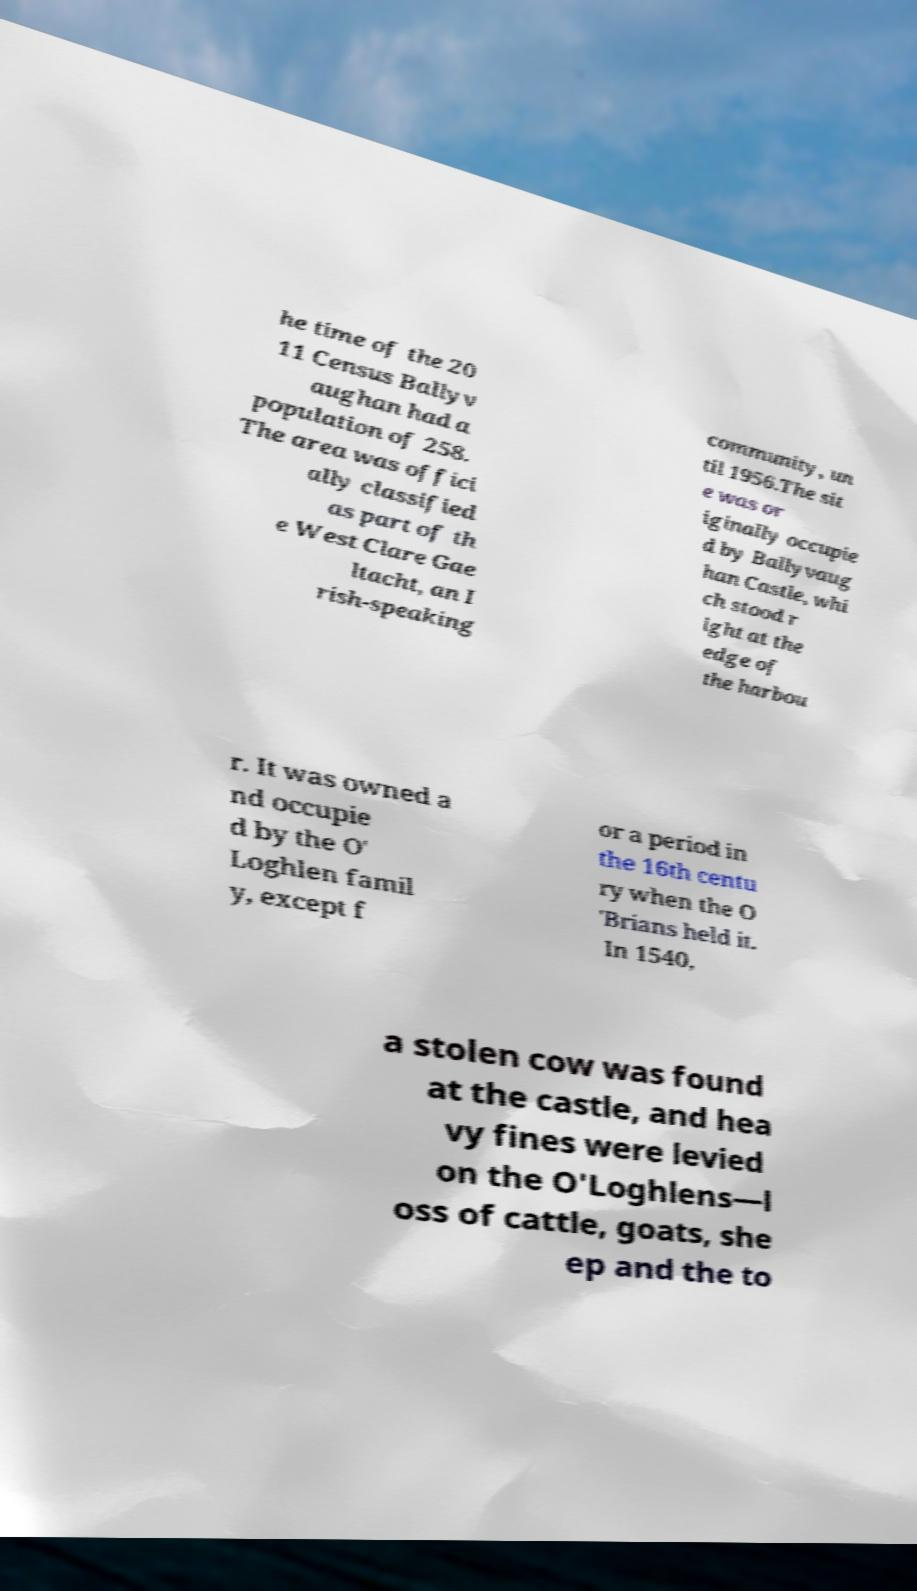Can you accurately transcribe the text from the provided image for me? he time of the 20 11 Census Ballyv aughan had a population of 258. The area was offici ally classified as part of th e West Clare Gae ltacht, an I rish-speaking community, un til 1956.The sit e was or iginally occupie d by Ballyvaug han Castle, whi ch stood r ight at the edge of the harbou r. It was owned a nd occupie d by the O' Loghlen famil y, except f or a period in the 16th centu ry when the O 'Brians held it. In 1540, a stolen cow was found at the castle, and hea vy fines were levied on the O'Loghlens—l oss of cattle, goats, she ep and the to 